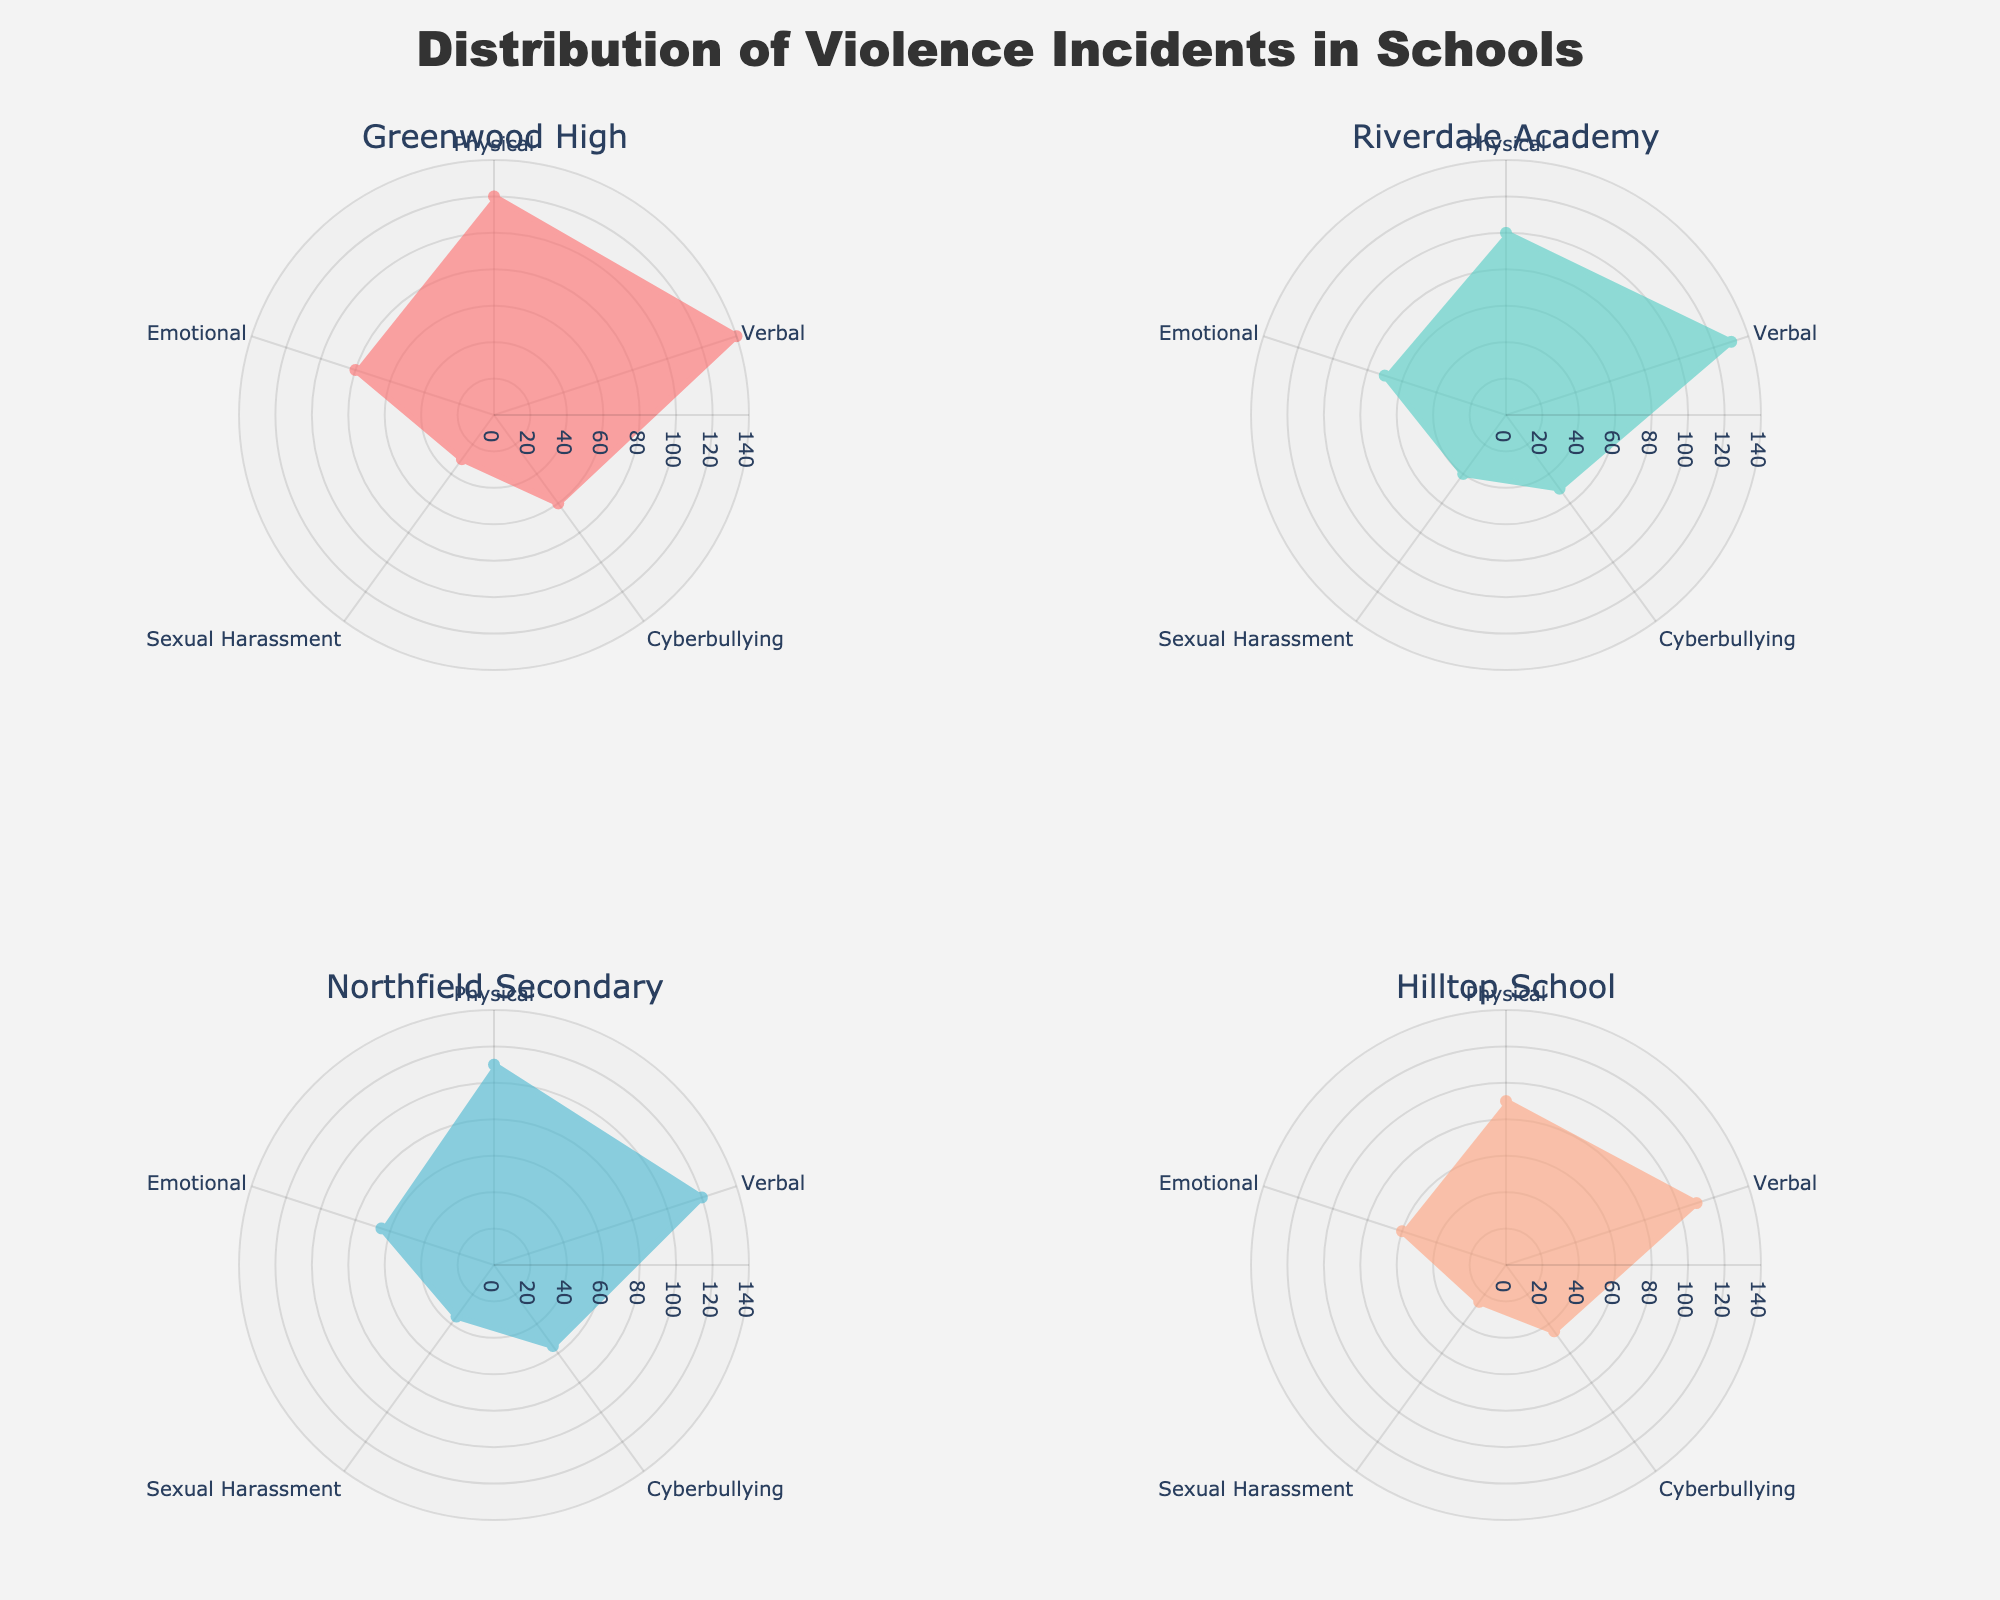What is the title of the plot? The title can be seen prominently at the top center of the plot.
Answer: Distribution of Violence Incidents in Schools Which type of violence has the highest number of incidents at Greenwood High? By observing the Greenwood High subplot, locate the longest radius, which corresponds to the highest number of incidents.
Answer: Verbal What is the common color used for the school's data in the subplots? By examining all subplots, notice that each school is represented with a unique shade.
Answer: Different shades for each school For Hilltop School, which type of violence has the second-highest number of incidents? In the Hilltop School subplot, identify the second longest radius.
Answer: Verbal Compare the number of physical violence incidents between Greenwood High and Riverdale Academy. Which school has more incidents? Compare the radial lengths for physical violence in the respective subplots of Greenwood High and Riverdale Academy.
Answer: Greenwood High Which school has the highest number of cyberbullying incidents? Compare the lengths of the radii associated with cyberbullying across all subplots.
Answer: Greenwood High Is there a type of violence that Hilltop School and Riverdale Academy have the same number of incidents? Look at both subplots and compare the radial lengths for each type of violence to find overlaps.
Answer: No What is the range of incidents for the emotional type of violence across all schools? Look at the radial lengths for emotional violence in all subplots, noting the minimum and maximum values. The minimum is 60 (Hilltop) and the maximum is 80 (Greenwood).
Answer: 60 to 80 Which type of violence has notably fewer incidents in all schools compared to others? Reviewing all subplots, identify the type of violence consistently represented by shorter radii.
Answer: Sexual Harassment 